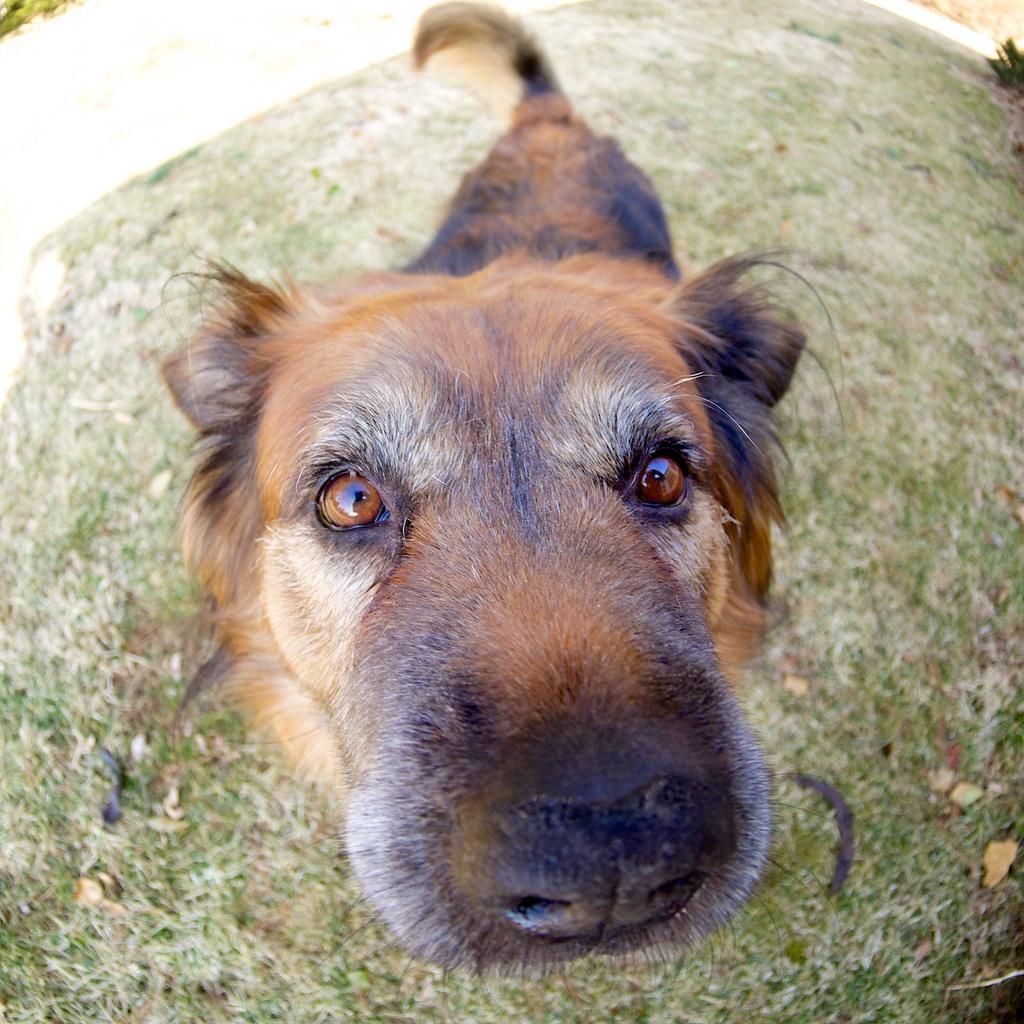Please provide a concise description of this image. This is an edited picture. I can see a dog, and in the background there is grass. 